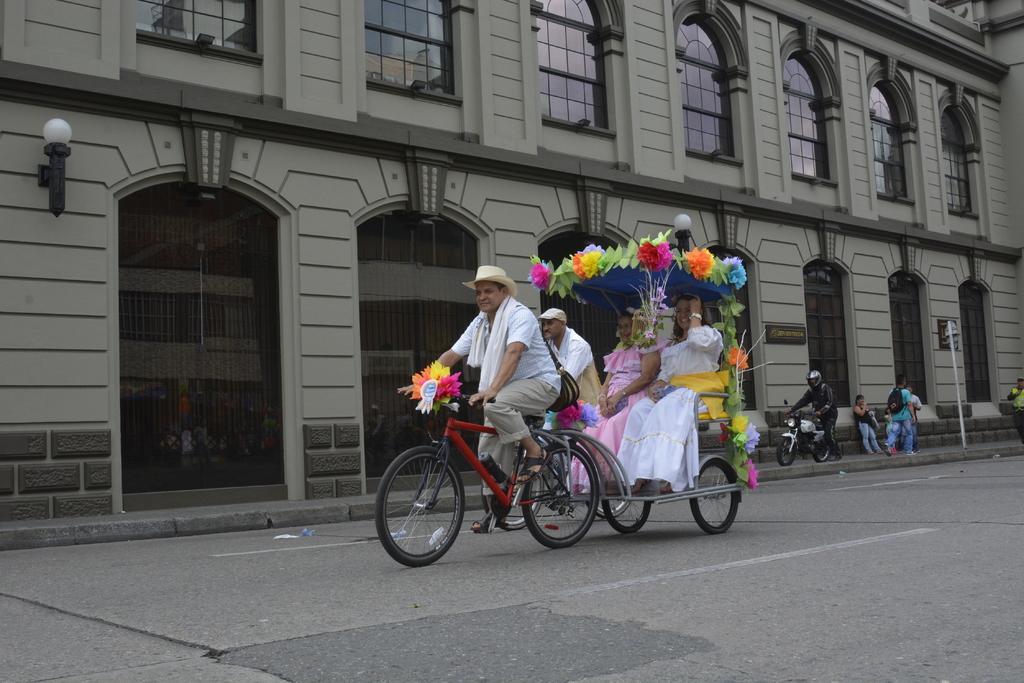Describe this image in one or two sentences. In this picture there were two bicycles and one cart is attached to one of the bicycle. There were two women sitting in the cart wearing two long frocks and smiling. The cart was decorated with flowers and leaves. The person riding on the bicycle wearing a white t shirt, cream pant and a hat and a second person is also wearing white T shirt and a hat. In the sidewalk there were group of people standing and walking. There is a another vehicle and a person holding it, wearing a helmet and black suits. In the background there is a building with too many windows and gates. 